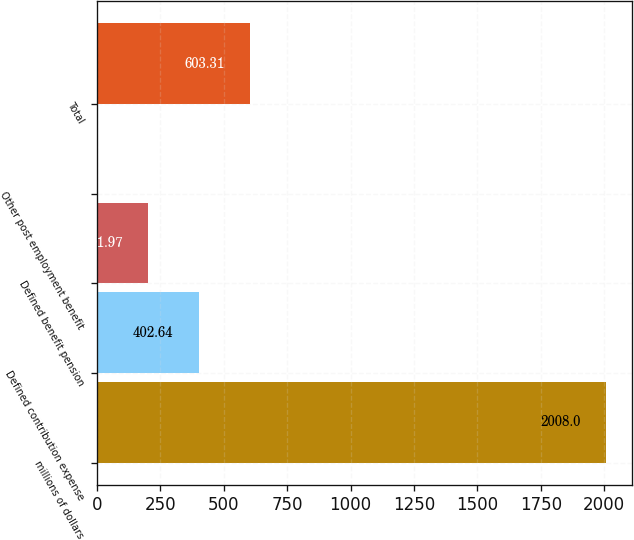Convert chart to OTSL. <chart><loc_0><loc_0><loc_500><loc_500><bar_chart><fcel>millions of dollars<fcel>Defined contribution expense<fcel>Defined benefit pension<fcel>Other post employment benefit<fcel>Total<nl><fcel>2008<fcel>402.64<fcel>201.97<fcel>1.3<fcel>603.31<nl></chart> 